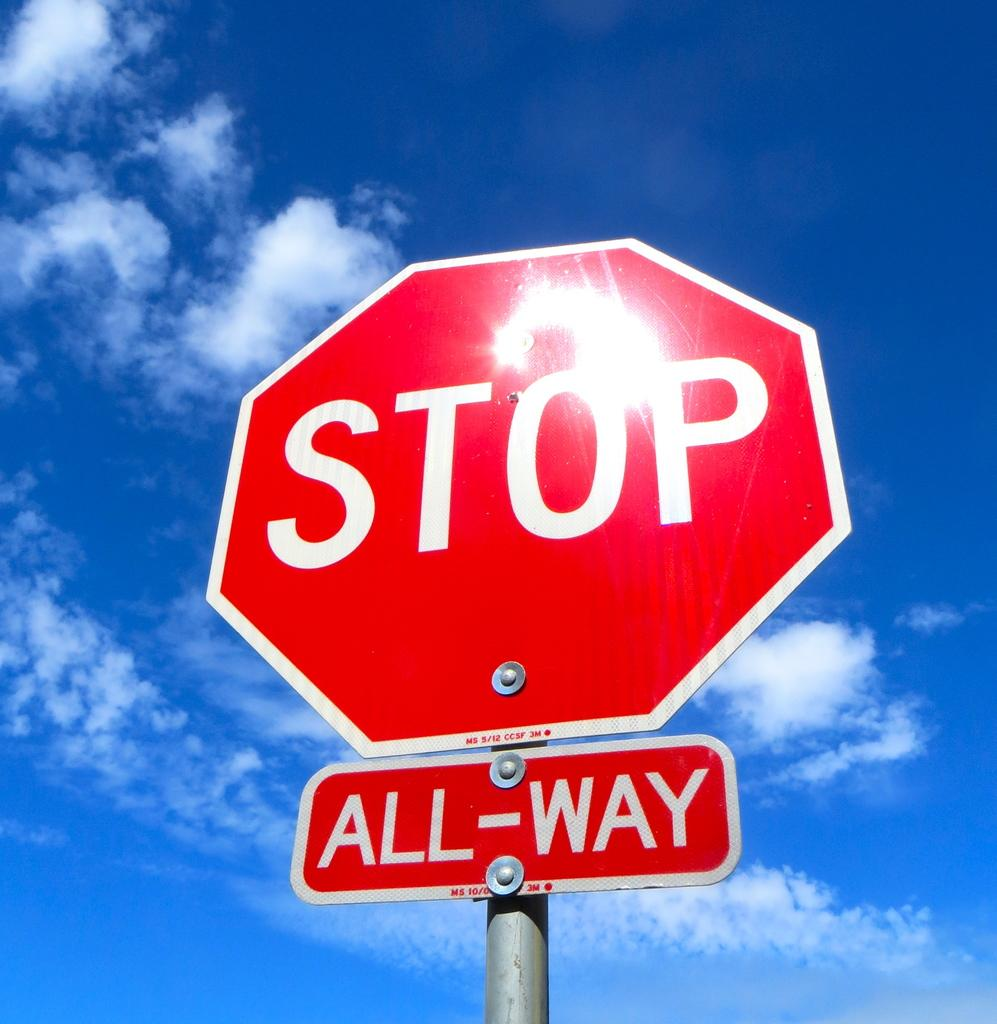Provide a one-sentence caption for the provided image. A red stop sign with an All-Way bellow the sign in front of a blue sky. 